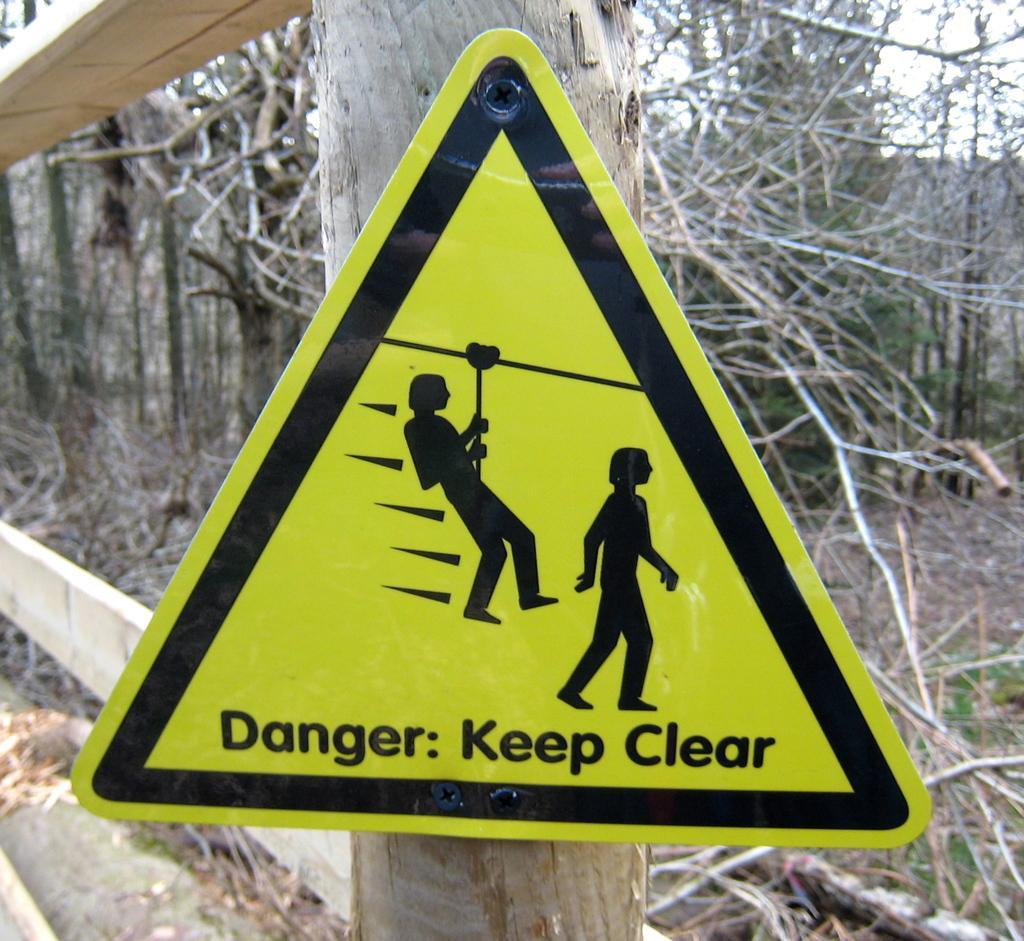How would you summarize this image in a sentence or two? In this picture we can see a signboard on a wooden pole and in the background we can see trees. 